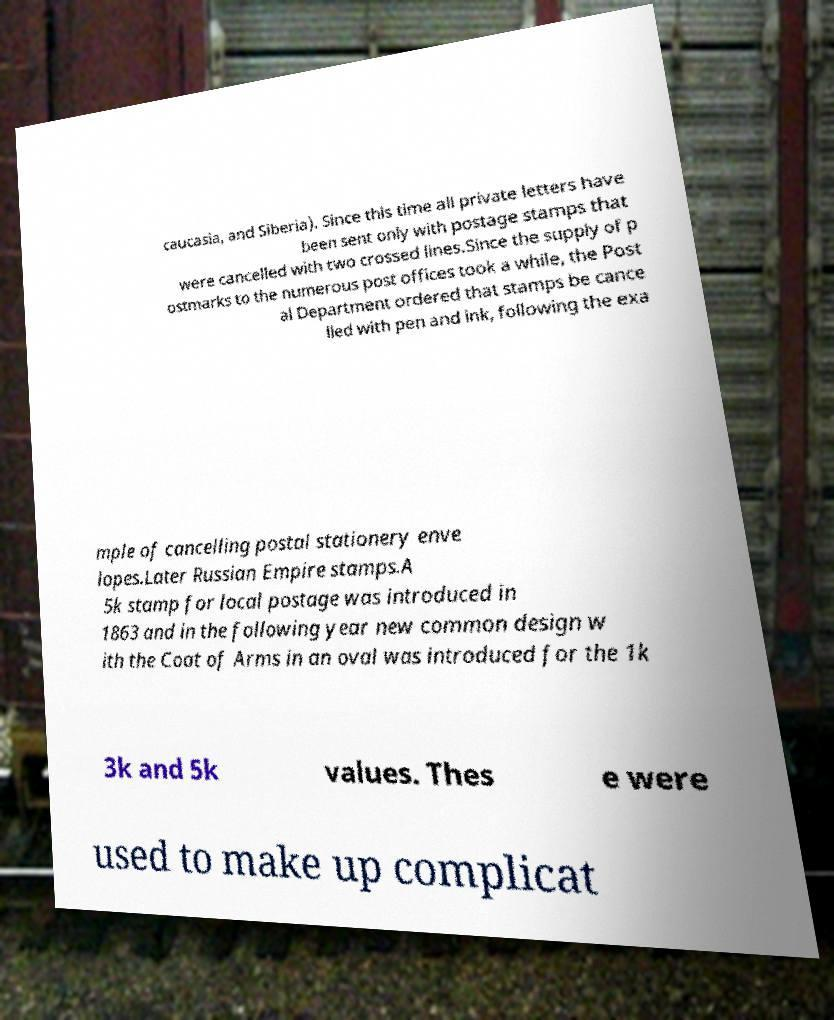What messages or text are displayed in this image? I need them in a readable, typed format. caucasia, and Siberia). Since this time all private letters have been sent only with postage stamps that were cancelled with two crossed lines.Since the supply of p ostmarks to the numerous post offices took a while, the Post al Department ordered that stamps be cance lled with pen and ink, following the exa mple of cancelling postal stationery enve lopes.Later Russian Empire stamps.A 5k stamp for local postage was introduced in 1863 and in the following year new common design w ith the Coat of Arms in an oval was introduced for the 1k 3k and 5k values. Thes e were used to make up complicat 